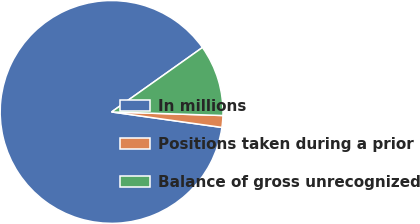<chart> <loc_0><loc_0><loc_500><loc_500><pie_chart><fcel>In millions<fcel>Positions taken during a prior<fcel>Balance of gross unrecognized<nl><fcel>87.96%<fcel>1.71%<fcel>10.33%<nl></chart> 